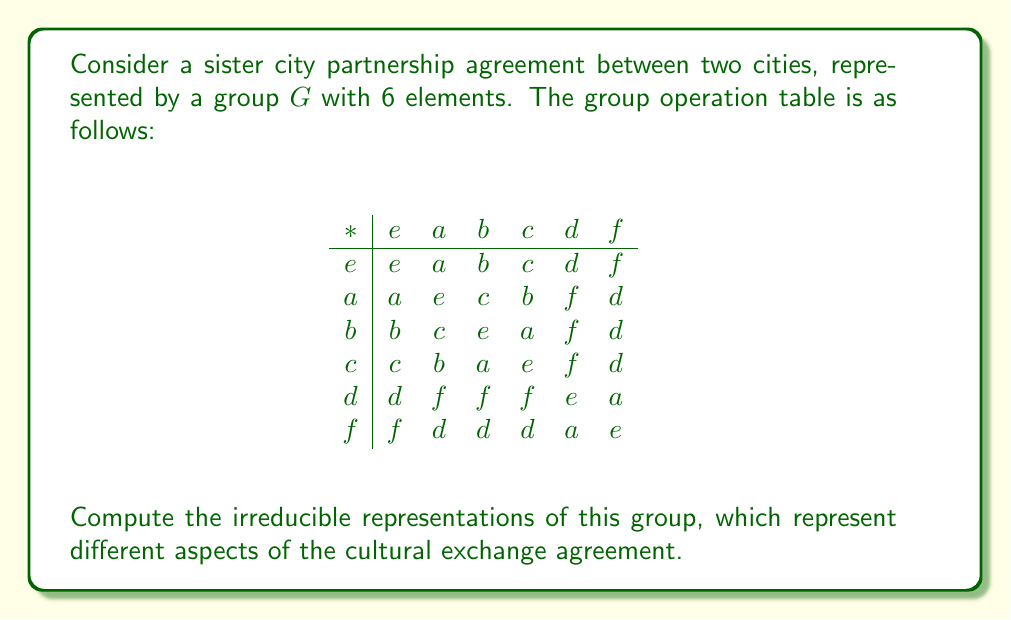Provide a solution to this math problem. To find the irreducible representations of the group $G$, we'll follow these steps:

1) First, determine the conjugacy classes of $G$:
   - $\{e\}$
   - $\{a, b, c\}$
   - $\{d, f\}$

2) The number of conjugacy classes equals the number of irreducible representations. So, there are 3 irreducible representations.

3) Let's call these representations $\rho_1$, $\rho_2$, and $\rho_3$.

4) The sum of squares of dimensions of irreducible representations equals the order of the group:
   $\dim(\rho_1)^2 + \dim(\rho_2)^2 + \dim(\rho_3)^2 = 6$

5) The only integer solution for this equation is $1^2 + 1^2 + 2^2 = 6$

6) So, we have two 1-dimensional representations and one 2-dimensional representation.

7) For the 1-dimensional representations:
   - $\rho_1$ is the trivial representation: $\rho_1(g) = 1$ for all $g \in G$
   - $\rho_2(e) = 1$, $\rho_2(a) = \rho_2(b) = \rho_2(c) = 1$, $\rho_2(d) = \rho_2(f) = -1$

8) For the 2-dimensional representation $\rho_3$:
   - $\rho_3(e) = \begin{pmatrix} 1 & 0 \\ 0 & 1 \end{pmatrix}$
   - $\rho_3(a) = \rho_3(b) = \rho_3(c) = \begin{pmatrix} -\frac{1}{2} & \frac{\sqrt{3}}{2} \\ -\frac{\sqrt{3}}{2} & -\frac{1}{2} \end{pmatrix}$
   - $\rho_3(d) = \rho_3(f) = \begin{pmatrix} -1 & 0 \\ 0 & 1 \end{pmatrix}$

These representations correspond to different aspects of the cultural exchange agreement, such as overall cooperation (trivial representation), mutual respect (sign representation), and detailed collaborative projects (2-dimensional representation).
Answer: $\rho_1(g) = 1$, $\rho_2(g) = \pm 1$, $\rho_3(g) \in \{\begin{pmatrix} 1 & 0 \\ 0 & 1 \end{pmatrix}, \begin{pmatrix} -\frac{1}{2} & \frac{\sqrt{3}}{2} \\ -\frac{\sqrt{3}}{2} & -\frac{1}{2} \end{pmatrix}, \begin{pmatrix} -1 & 0 \\ 0 & 1 \end{pmatrix}\}$ 